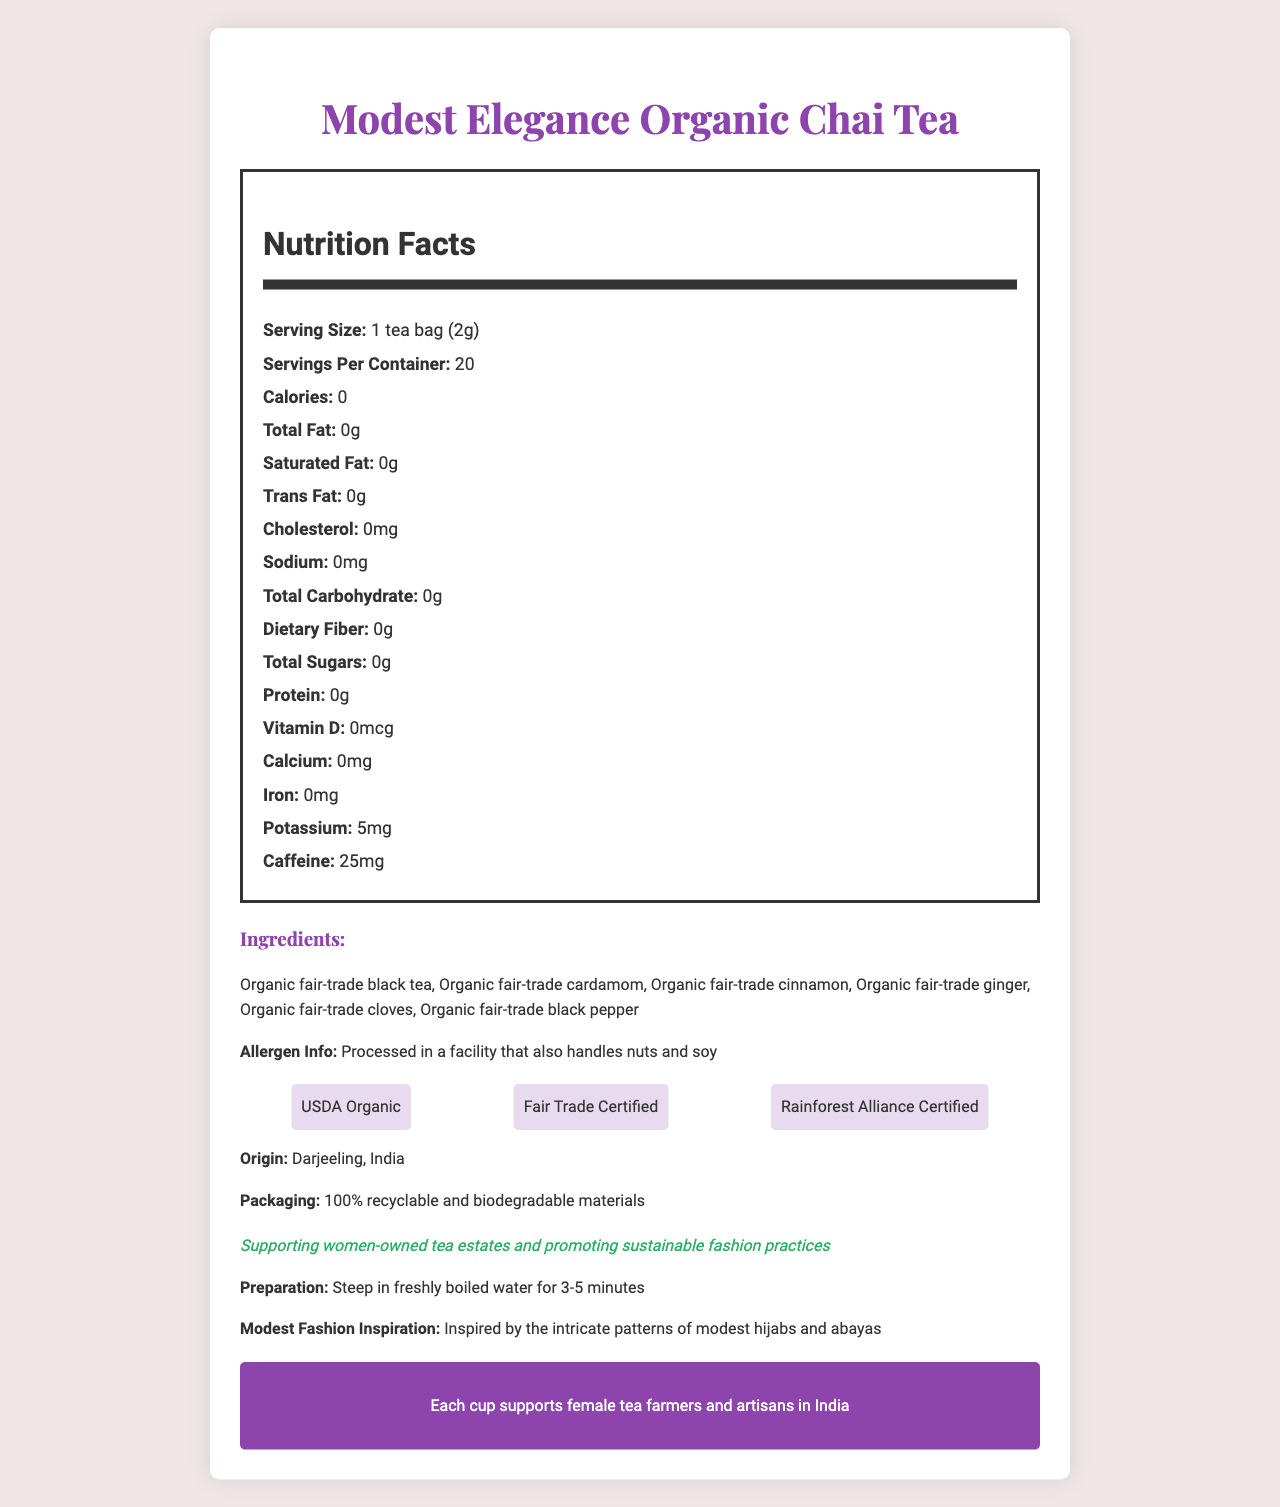what is the serving size? The serving size is readily available in the Nutrition Facts section and is listed as "1 tea bag (2g)".
Answer: 1 tea bag (2g) how much caffeine is in one serving? The Nutrition Facts section mentions that one serving contains 25mg of caffeine.
Answer: 25mg what certifications does the product have? These certifications are listed in a dedicated section in the lower part of the document.
Answer: USDA Organic, Fair Trade Certified, Rainforest Alliance Certified what is the modest fashion inspiration behind this tea? This information is provided under the "Modest Fashion Inspiration" section.
Answer: Inspired by the intricate patterns of modest hijabs and abayas how many servings are there per container? The Nutrition Facts section states that there are 20 servings per container.
Answer: 20 which ingredient is not part of the tea? A. Organic fair-trade black tea B. Organic fair-trade cardamom C. Organic fair-trade vanilla D. Organic fair-trade cinnamon The listed ingredients include organic fair-trade black tea, cardamom, cinnamon, ginger, cloves, and black pepper, but not vanilla.
Answer: C how much potassium is in one serving? A. 0mg B. 5mg C. 10mg D. 25mg The Nutrition Facts section mentions that one serving contains 5mg of potassium.
Answer: B is there any sodium in the tea? According to the Nutrition Facts section, there is 0mg of sodium in the tea.
Answer: No does the tea contain any added sugars? The Nutrition Facts section states that the tea has 0g of total sugars.
Answer: No is the packaging environmentally friendly? The document specifies that the packaging is made from 100% recyclable and biodegradable materials.
Answer: Yes does the tea contain any allergens? Although the tea itself does not contain allergens, it is processed in a facility that handles nuts and soy, which is indicated in the allergen info.
Answer: Processed in a facility that also handles nuts and soy where is the tea originally from? This information is clearly mentioned under "Origin".
Answer: Darjeeling, India what minerals or vitamins does the tea include? According to the Nutrition Facts section, the tea contains 5mg of potassium, but it does not have calcium, iron, or vitamin D.
Answer: Potassium what message is conveyed about empowerment? This message is provided in the empowerment section at the bottom of the document.
Answer: Each cup supports female tea farmers and artisans in India describe the main idea of this document The document outlines various aspects of "Modest Elegance Organic Chai Tea," including its nutritional content, ethical certifications, ingredient list, and the social initiative to support female tea farmers, framed within a modest fashion context.
Answer: The document provides detailed information about "Modest Elegance Organic Chai Tea," highlighting its nutritional facts, organic and fair-trade certifications, ingredients, allergen info, origin, and packaging. Additionally, it mentions the modest fashion inspiration and emphasizes the empowerment of women through its production. what is the percentage of daily iron value in this tea? The document does not include any percentage of daily values, thus it's impossible to determine the daily iron value.
Answer: Not enough information 